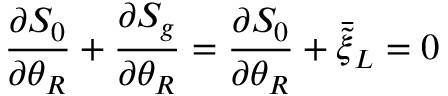<formula> <loc_0><loc_0><loc_500><loc_500>\frac { \partial S _ { 0 } } { \partial \theta _ { R } } + \frac { \partial S _ { g } } { \partial \theta _ { R } } = \frac { \partial S _ { 0 } } { \partial \theta _ { R } } + \bar { \tilde { \xi } } _ { L } = 0</formula> 